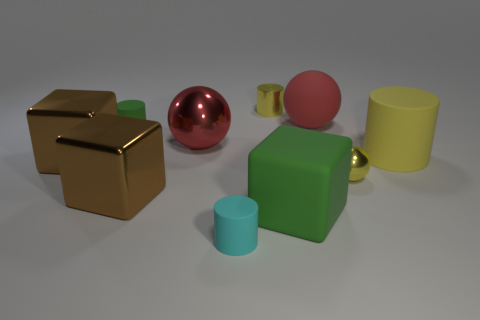Subtract all cylinders. How many objects are left? 6 Add 4 cyan rubber cylinders. How many cyan rubber cylinders are left? 5 Add 6 cyan rubber objects. How many cyan rubber objects exist? 7 Subtract 1 brown blocks. How many objects are left? 9 Subtract all big gray rubber objects. Subtract all large red matte spheres. How many objects are left? 9 